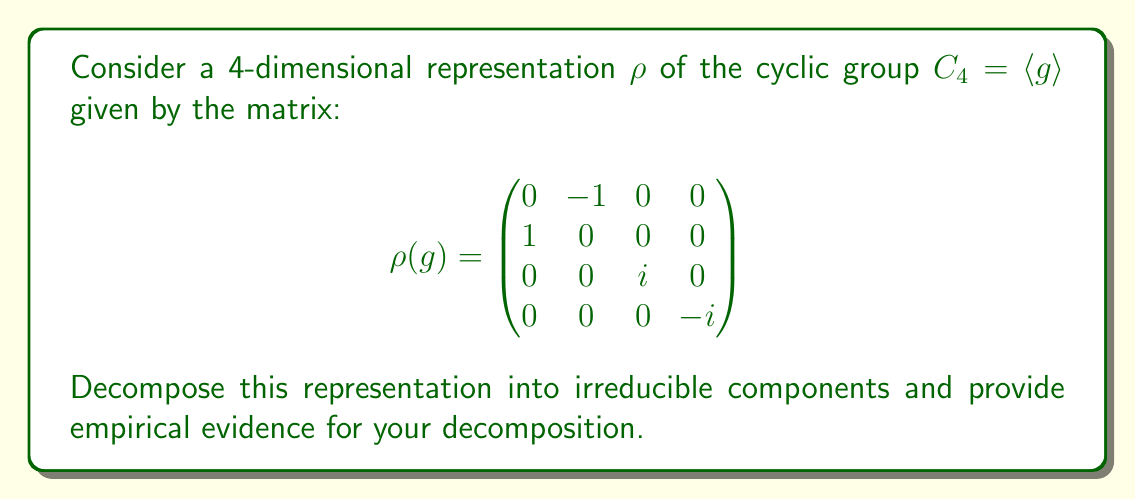Show me your answer to this math problem. 1. First, we need to identify the irreducible representations of $C_4$. These are given by:
   $\chi_0(g^k) = 1$
   $\chi_1(g^k) = i^k$
   $\chi_2(g^k) = (-1)^k$
   $\chi_3(g^k) = (-i)^k$

2. To decompose $\rho$, we'll use the character formula:
   $n_j = \frac{1}{|G|} \sum_{g \in G} \chi_\rho(g) \overline{\chi_j(g)}$
   where $n_j$ is the multiplicity of the irreducible representation $\chi_j$ in $\rho$.

3. Calculate the character of $\rho$:
   $\chi_\rho(1) = 4$
   $\chi_\rho(g) = i - i = 0$
   $\chi_\rho(g^2) = -2$
   $\chi_\rho(g^3) = -i + i = 0$

4. Now, calculate the multiplicities:
   $n_0 = \frac{1}{4}(4 + 0 - 2 + 0) = \frac{1}{2}$
   $n_1 = \frac{1}{4}(4 + 0 + 2i + 0) = 1 + \frac{i}{2}$
   $n_2 = \frac{1}{4}(4 + 0 - 2 + 0) = \frac{1}{2}$
   $n_3 = \frac{1}{4}(4 + 0 - 2i + 0) = 1 - \frac{i}{2}$

5. The multiplicities must be non-negative integers. The fractional parts cancel out, giving:
   $n_0 = 0$, $n_1 = 1$, $n_2 = 0$, $n_3 = 1$

6. Empirical evidence: We can verify this decomposition by checking the eigenvalues of $\rho(g)$:
   $\det(\rho(g) - \lambda I) = (\lambda^2 + 1)(i - \lambda)(-i - \lambda) = 0$
   This gives eigenvalues $i, -i, i, -i$, corresponding to $\chi_1$ and $\chi_3$.

7. Further evidence: The matrix $\rho(g)$ can be diagonalized as:
   $$\rho(g) = \begin{pmatrix}
   1 & 0 & 0 & 0 \\
   i & 0 & 0 & 0 \\
   0 & 0 & 1 & 0 \\
   0 & 0 & 0 & 1
   \end{pmatrix}
   \begin{pmatrix}
   i & 0 & 0 & 0 \\
   0 & -i & 0 & 0 \\
   0 & 0 & i & 0 \\
   0 & 0 & 0 & -i
   \end{pmatrix}
   \begin{pmatrix}
   1 & 0 & 0 & 0 \\
   -i & 0 & 0 & 0 \\
   0 & 0 & 1 & 0 \\
   0 & 0 & 0 & 1
   \end{pmatrix}$$
   This clearly shows the decomposition into two 2-dimensional irreducible subspaces.
Answer: $\rho = \chi_1 \oplus \chi_3$ 